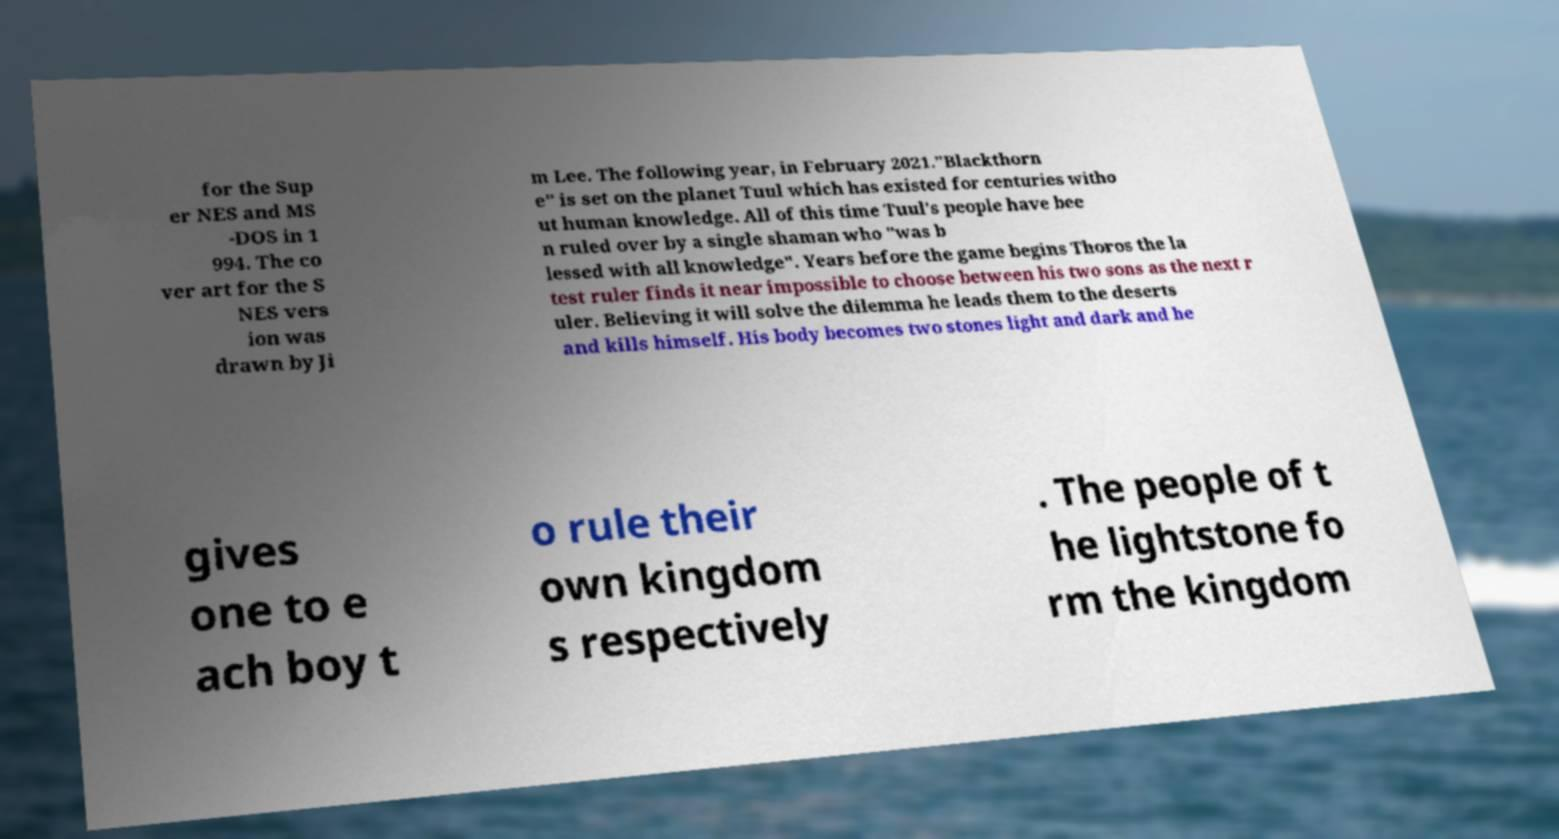Can you accurately transcribe the text from the provided image for me? for the Sup er NES and MS -DOS in 1 994. The co ver art for the S NES vers ion was drawn by Ji m Lee. The following year, in February 2021."Blackthorn e" is set on the planet Tuul which has existed for centuries witho ut human knowledge. All of this time Tuul's people have bee n ruled over by a single shaman who "was b lessed with all knowledge". Years before the game begins Thoros the la test ruler finds it near impossible to choose between his two sons as the next r uler. Believing it will solve the dilemma he leads them to the deserts and kills himself. His body becomes two stones light and dark and he gives one to e ach boy t o rule their own kingdom s respectively . The people of t he lightstone fo rm the kingdom 